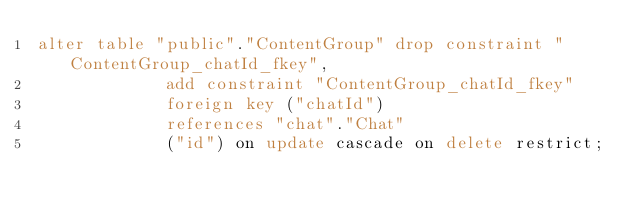Convert code to text. <code><loc_0><loc_0><loc_500><loc_500><_SQL_>alter table "public"."ContentGroup" drop constraint "ContentGroup_chatId_fkey",
             add constraint "ContentGroup_chatId_fkey"
             foreign key ("chatId")
             references "chat"."Chat"
             ("id") on update cascade on delete restrict;
</code> 